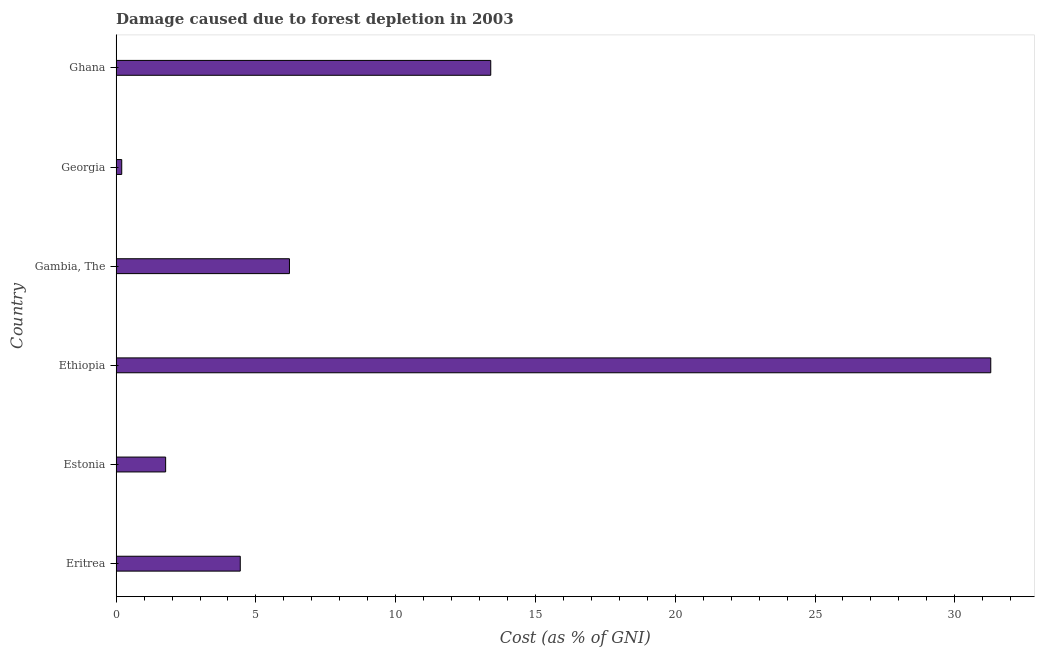Does the graph contain grids?
Your answer should be compact. No. What is the title of the graph?
Your answer should be compact. Damage caused due to forest depletion in 2003. What is the label or title of the X-axis?
Give a very brief answer. Cost (as % of GNI). What is the label or title of the Y-axis?
Your answer should be very brief. Country. What is the damage caused due to forest depletion in Eritrea?
Ensure brevity in your answer.  4.44. Across all countries, what is the maximum damage caused due to forest depletion?
Provide a short and direct response. 31.29. Across all countries, what is the minimum damage caused due to forest depletion?
Offer a very short reply. 0.2. In which country was the damage caused due to forest depletion maximum?
Make the answer very short. Ethiopia. In which country was the damage caused due to forest depletion minimum?
Your response must be concise. Georgia. What is the sum of the damage caused due to forest depletion?
Give a very brief answer. 57.3. What is the difference between the damage caused due to forest depletion in Eritrea and Estonia?
Your answer should be very brief. 2.67. What is the average damage caused due to forest depletion per country?
Give a very brief answer. 9.55. What is the median damage caused due to forest depletion?
Your response must be concise. 5.32. What is the ratio of the damage caused due to forest depletion in Eritrea to that in Georgia?
Offer a very short reply. 22.13. Is the damage caused due to forest depletion in Ethiopia less than that in Georgia?
Make the answer very short. No. Is the difference between the damage caused due to forest depletion in Estonia and Ghana greater than the difference between any two countries?
Your response must be concise. No. What is the difference between the highest and the second highest damage caused due to forest depletion?
Keep it short and to the point. 17.89. Is the sum of the damage caused due to forest depletion in Estonia and Ethiopia greater than the maximum damage caused due to forest depletion across all countries?
Offer a very short reply. Yes. What is the difference between the highest and the lowest damage caused due to forest depletion?
Make the answer very short. 31.09. What is the difference between two consecutive major ticks on the X-axis?
Offer a very short reply. 5. What is the Cost (as % of GNI) in Eritrea?
Your response must be concise. 4.44. What is the Cost (as % of GNI) in Estonia?
Provide a short and direct response. 1.77. What is the Cost (as % of GNI) of Ethiopia?
Make the answer very short. 31.29. What is the Cost (as % of GNI) in Gambia, The?
Your answer should be very brief. 6.2. What is the Cost (as % of GNI) in Georgia?
Offer a very short reply. 0.2. What is the Cost (as % of GNI) of Ghana?
Your answer should be compact. 13.4. What is the difference between the Cost (as % of GNI) in Eritrea and Estonia?
Give a very brief answer. 2.67. What is the difference between the Cost (as % of GNI) in Eritrea and Ethiopia?
Provide a short and direct response. -26.85. What is the difference between the Cost (as % of GNI) in Eritrea and Gambia, The?
Provide a short and direct response. -1.76. What is the difference between the Cost (as % of GNI) in Eritrea and Georgia?
Your answer should be very brief. 4.24. What is the difference between the Cost (as % of GNI) in Eritrea and Ghana?
Your response must be concise. -8.96. What is the difference between the Cost (as % of GNI) in Estonia and Ethiopia?
Give a very brief answer. -29.51. What is the difference between the Cost (as % of GNI) in Estonia and Gambia, The?
Provide a succinct answer. -4.43. What is the difference between the Cost (as % of GNI) in Estonia and Georgia?
Your answer should be very brief. 1.57. What is the difference between the Cost (as % of GNI) in Estonia and Ghana?
Ensure brevity in your answer.  -11.63. What is the difference between the Cost (as % of GNI) in Ethiopia and Gambia, The?
Your answer should be very brief. 25.09. What is the difference between the Cost (as % of GNI) in Ethiopia and Georgia?
Keep it short and to the point. 31.09. What is the difference between the Cost (as % of GNI) in Ethiopia and Ghana?
Give a very brief answer. 17.89. What is the difference between the Cost (as % of GNI) in Gambia, The and Georgia?
Provide a succinct answer. 6. What is the difference between the Cost (as % of GNI) in Gambia, The and Ghana?
Your answer should be compact. -7.2. What is the difference between the Cost (as % of GNI) in Georgia and Ghana?
Your answer should be compact. -13.2. What is the ratio of the Cost (as % of GNI) in Eritrea to that in Estonia?
Offer a very short reply. 2.51. What is the ratio of the Cost (as % of GNI) in Eritrea to that in Ethiopia?
Ensure brevity in your answer.  0.14. What is the ratio of the Cost (as % of GNI) in Eritrea to that in Gambia, The?
Provide a short and direct response. 0.72. What is the ratio of the Cost (as % of GNI) in Eritrea to that in Georgia?
Provide a succinct answer. 22.13. What is the ratio of the Cost (as % of GNI) in Eritrea to that in Ghana?
Ensure brevity in your answer.  0.33. What is the ratio of the Cost (as % of GNI) in Estonia to that in Ethiopia?
Ensure brevity in your answer.  0.06. What is the ratio of the Cost (as % of GNI) in Estonia to that in Gambia, The?
Your response must be concise. 0.29. What is the ratio of the Cost (as % of GNI) in Estonia to that in Georgia?
Keep it short and to the point. 8.83. What is the ratio of the Cost (as % of GNI) in Estonia to that in Ghana?
Ensure brevity in your answer.  0.13. What is the ratio of the Cost (as % of GNI) in Ethiopia to that in Gambia, The?
Ensure brevity in your answer.  5.05. What is the ratio of the Cost (as % of GNI) in Ethiopia to that in Georgia?
Provide a short and direct response. 155.94. What is the ratio of the Cost (as % of GNI) in Ethiopia to that in Ghana?
Provide a short and direct response. 2.33. What is the ratio of the Cost (as % of GNI) in Gambia, The to that in Georgia?
Make the answer very short. 30.9. What is the ratio of the Cost (as % of GNI) in Gambia, The to that in Ghana?
Offer a very short reply. 0.46. What is the ratio of the Cost (as % of GNI) in Georgia to that in Ghana?
Your response must be concise. 0.01. 